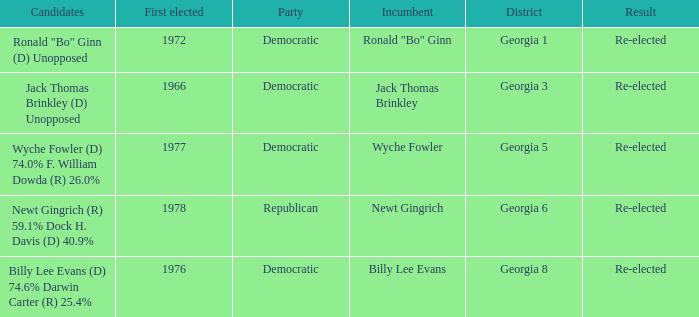1% and dock h. davis (d) 4 1.0. 